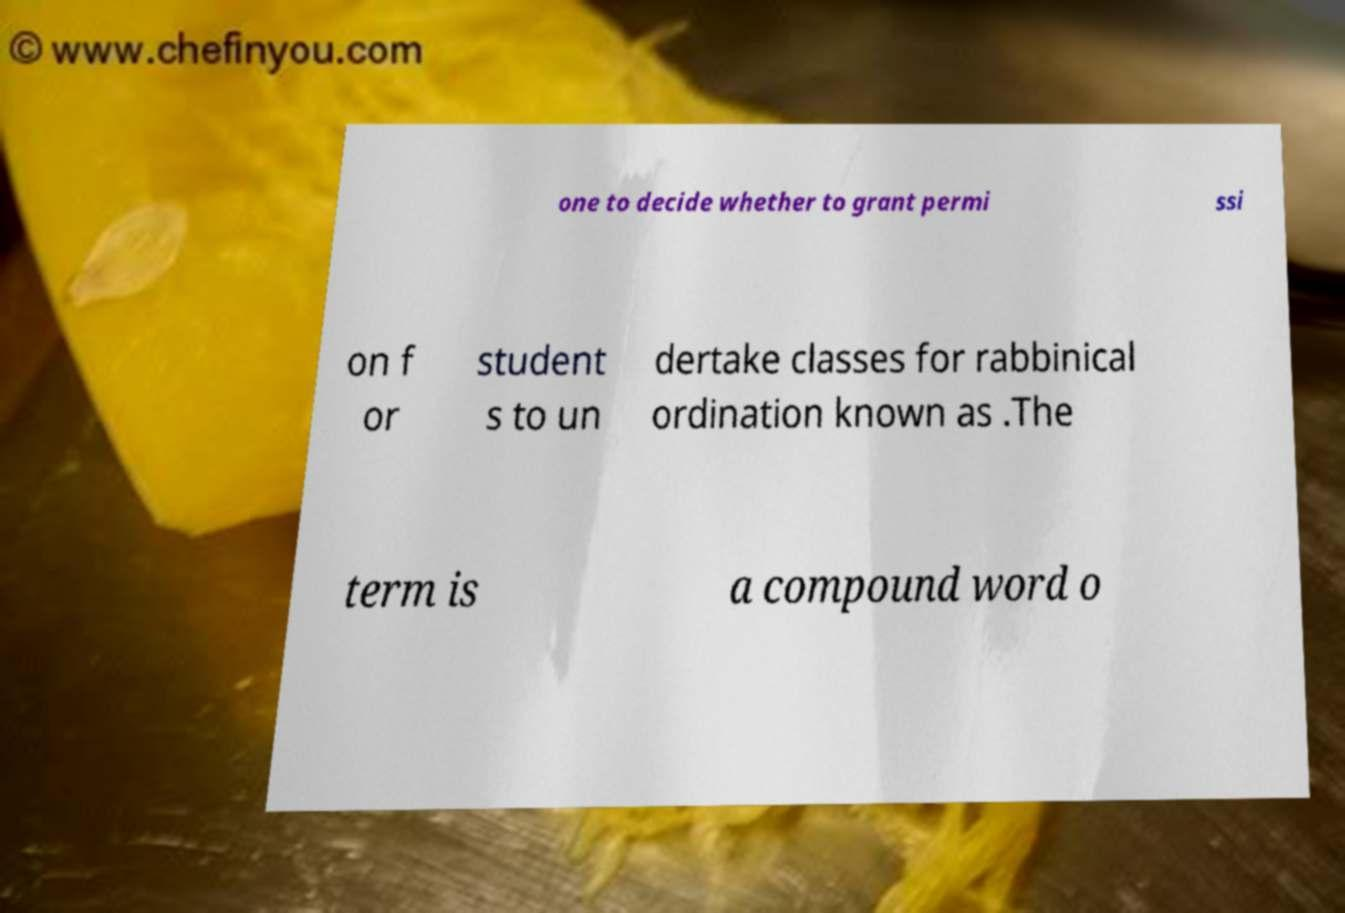Please identify and transcribe the text found in this image. one to decide whether to grant permi ssi on f or student s to un dertake classes for rabbinical ordination known as .The term is a compound word o 